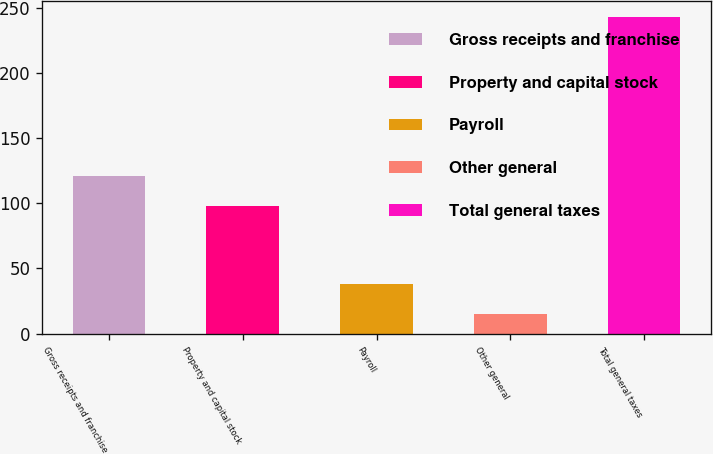<chart> <loc_0><loc_0><loc_500><loc_500><bar_chart><fcel>Gross receipts and franchise<fcel>Property and capital stock<fcel>Payroll<fcel>Other general<fcel>Total general taxes<nl><fcel>120.8<fcel>98<fcel>37.8<fcel>15<fcel>243<nl></chart> 